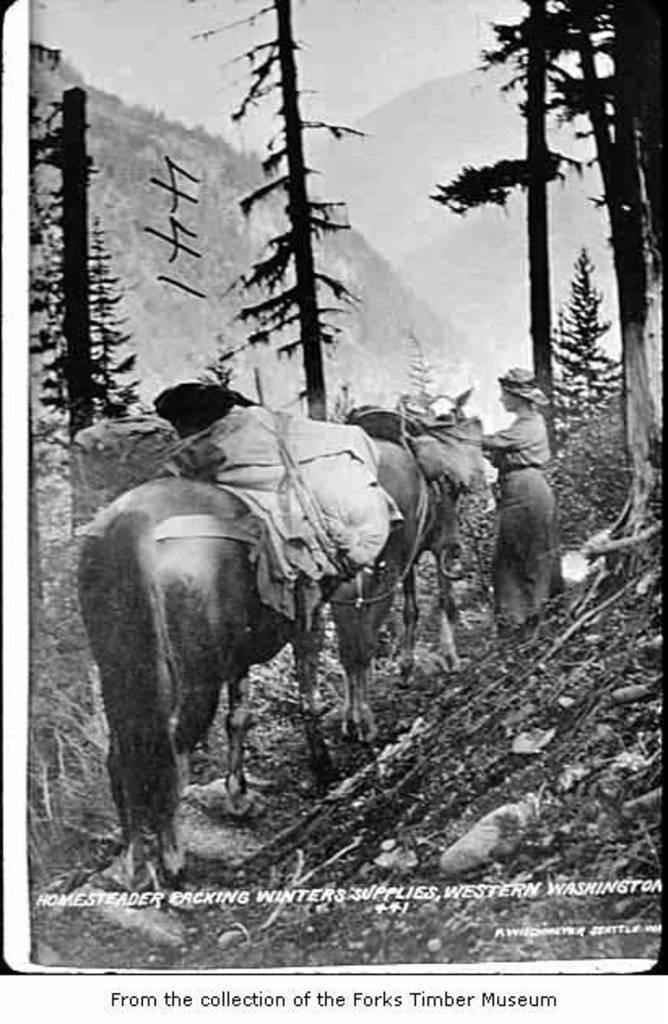Describe this image in one or two sentences. In this image I can see few animals and I can see the person standing. In the background I can see few trees and the image is in black and white. 